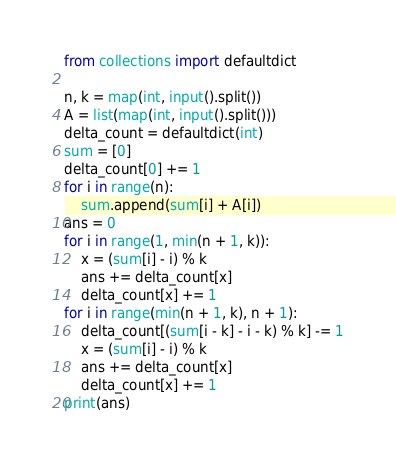Convert code to text. <code><loc_0><loc_0><loc_500><loc_500><_Python_>from collections import defaultdict

n, k = map(int, input().split())
A = list(map(int, input().split()))
delta_count = defaultdict(int)
sum = [0]
delta_count[0] += 1
for i in range(n):
    sum.append(sum[i] + A[i])
ans = 0
for i in range(1, min(n + 1, k)):
    x = (sum[i] - i) % k
    ans += delta_count[x]
    delta_count[x] += 1
for i in range(min(n + 1, k), n + 1):
    delta_count[(sum[i - k] - i - k) % k] -= 1
    x = (sum[i] - i) % k
    ans += delta_count[x]
    delta_count[x] += 1
print(ans)</code> 